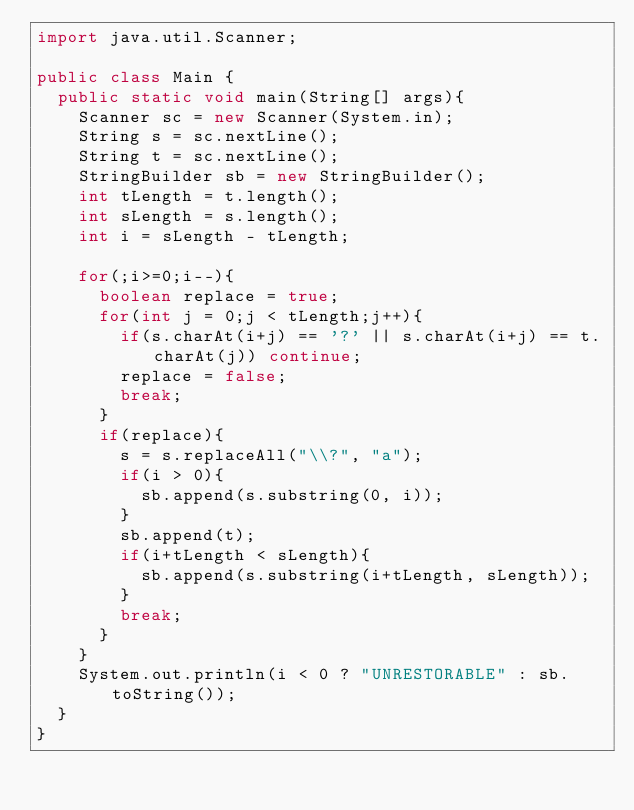<code> <loc_0><loc_0><loc_500><loc_500><_Java_>import java.util.Scanner;

public class Main {
	public static void main(String[] args){
		Scanner sc = new Scanner(System.in);
		String s = sc.nextLine();
		String t = sc.nextLine();
		StringBuilder sb = new StringBuilder();
		int tLength = t.length();
		int sLength = s.length();
		int i = sLength - tLength;

		for(;i>=0;i--){
			boolean replace = true;
			for(int j = 0;j < tLength;j++){
				if(s.charAt(i+j) == '?' || s.charAt(i+j) == t.charAt(j)) continue;
				replace = false;
				break;
			}
			if(replace){
				s = s.replaceAll("\\?", "a");
				if(i > 0){
					sb.append(s.substring(0, i));
				}
				sb.append(t);
				if(i+tLength < sLength){
					sb.append(s.substring(i+tLength, sLength));
				}
				break;
			}
		}
		System.out.println(i < 0 ? "UNRESTORABLE" : sb.toString());
	}
}
</code> 